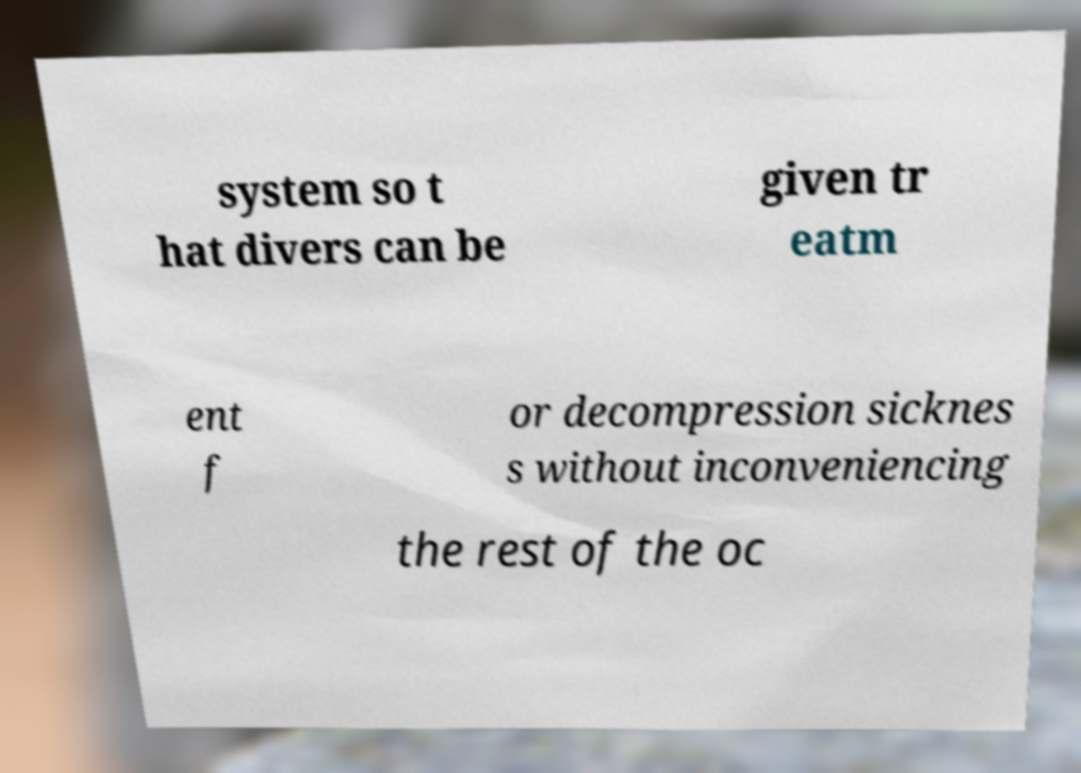I need the written content from this picture converted into text. Can you do that? system so t hat divers can be given tr eatm ent f or decompression sicknes s without inconveniencing the rest of the oc 